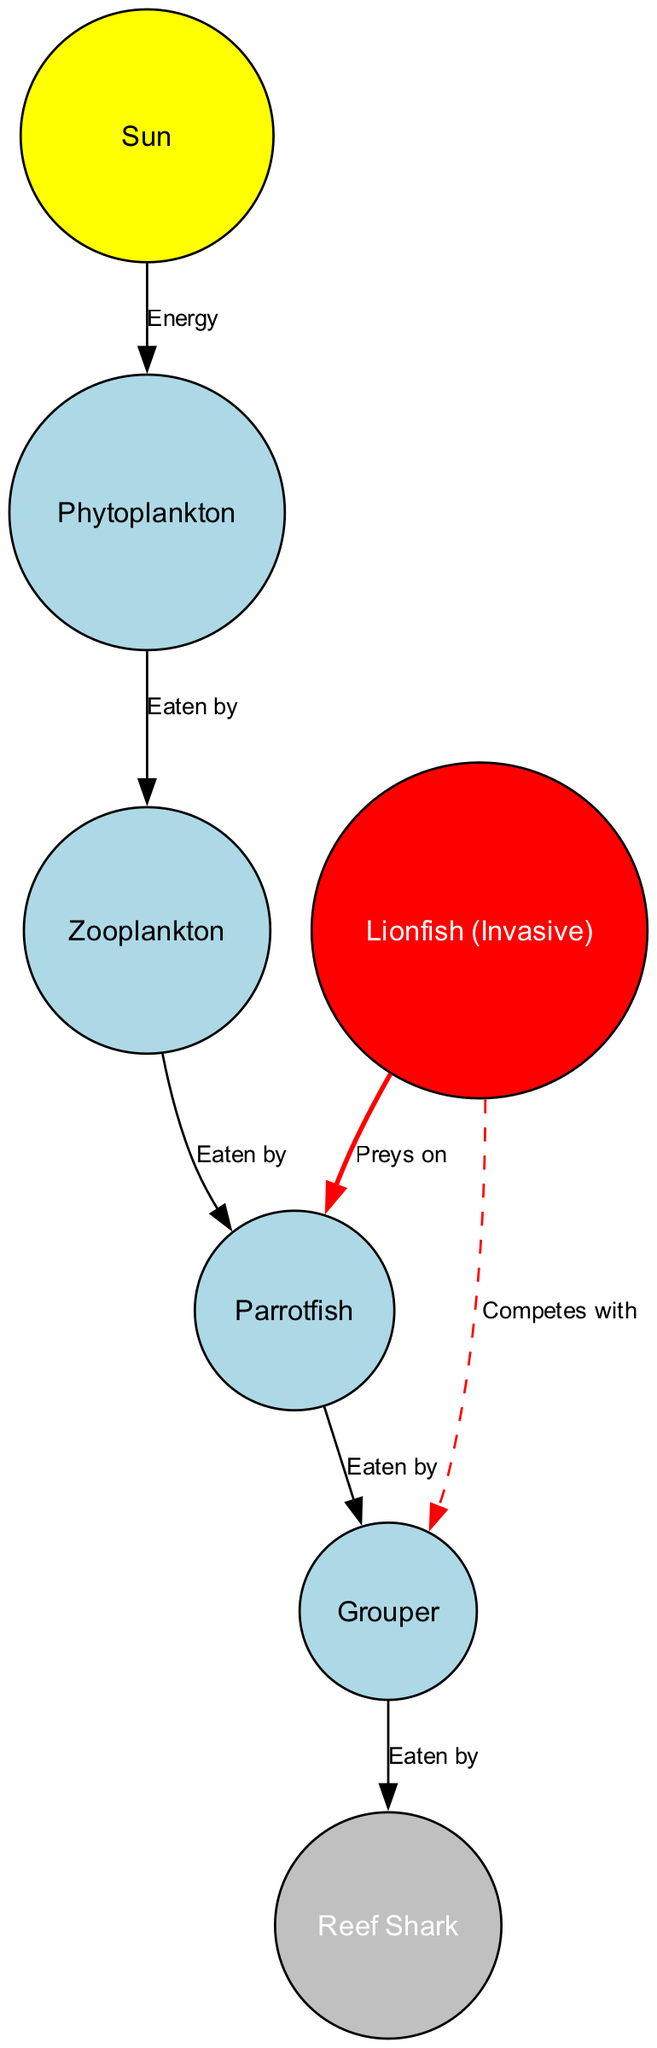What is the primary source of energy in the coral reef food chain? The diagram indicates that the energy source is the Sun, which is shown as the starting point of the food chain and connects to phytoplankton.
Answer: Sun How many nodes are present in the food chain? The diagram lists a total of seven unique nodes: Sun, Phytoplankton, Zooplankton, Parrotfish, Lionfish (Invasive), Grouper, and Reef Shark.
Answer: 7 Who preys on Parrotfish? The diagram illustrates that the Lionfish (Invasive) preys on the Parrotfish, indicated by a directed edge labeled 'Preys on' from Lionfish to Parrotfish.
Answer: Lionfish What is the relationship between Grouper and Reef Shark? The diagram shows that the Grouper is eaten by the Reef Shark, denoted by a directed edge labeled 'Eaten by' pointing from Grouper to Reef Shark.
Answer: Eaten by Excluding the Sun, which node is the top predator in the food chain? By examining the diagram, it indicates that the Reef Shark is the highest or top predator as it has no outgoing edges indicating that it is not preyed upon by any other species.
Answer: Reef Shark Which species competes with Grouper? The Lionfish (Invasive) is highlighted in the diagram as competing with the Grouper, as shown by a dashed edge labeled 'Competes with'.
Answer: Lionfish How many eating relationships are represented in the food chain? Reviewing the diagram reveals there are four distinct directed edges labeled 'Eaten by' that represent eating relationships, plus one 'Competes with' relationship, totaling five connections.
Answer: 4 Which type of species is Lionfish categorized as in this ecosystem? The diagram designates Lionfish explicitly as an invasive species, which significantly impacts the food chain dynamics in the coral reef ecosystem.
Answer: Invasive What do Zooplankton consume? According to the diagram, Zooplankton are shown to be eaten by the Parrotfish, as indicated by the directed edge labeled 'Eaten by'.
Answer: Parrotfish 